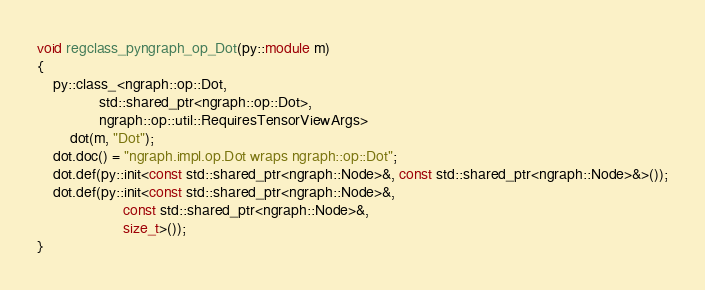Convert code to text. <code><loc_0><loc_0><loc_500><loc_500><_C++_>
void regclass_pyngraph_op_Dot(py::module m)
{
    py::class_<ngraph::op::Dot,
               std::shared_ptr<ngraph::op::Dot>,
               ngraph::op::util::RequiresTensorViewArgs>
        dot(m, "Dot");
    dot.doc() = "ngraph.impl.op.Dot wraps ngraph::op::Dot";
    dot.def(py::init<const std::shared_ptr<ngraph::Node>&, const std::shared_ptr<ngraph::Node>&>());
    dot.def(py::init<const std::shared_ptr<ngraph::Node>&,
                     const std::shared_ptr<ngraph::Node>&,
                     size_t>());
}
</code> 